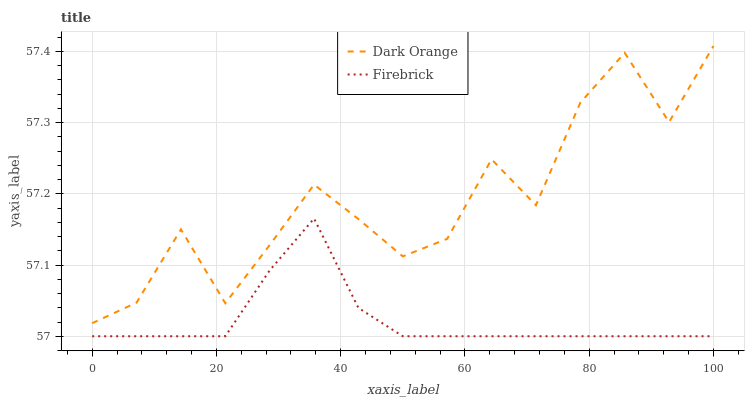Does Firebrick have the minimum area under the curve?
Answer yes or no. Yes. Does Dark Orange have the maximum area under the curve?
Answer yes or no. Yes. Does Firebrick have the maximum area under the curve?
Answer yes or no. No. Is Firebrick the smoothest?
Answer yes or no. Yes. Is Dark Orange the roughest?
Answer yes or no. Yes. Is Firebrick the roughest?
Answer yes or no. No. Does Firebrick have the lowest value?
Answer yes or no. Yes. Does Dark Orange have the highest value?
Answer yes or no. Yes. Does Firebrick have the highest value?
Answer yes or no. No. Is Firebrick less than Dark Orange?
Answer yes or no. Yes. Is Dark Orange greater than Firebrick?
Answer yes or no. Yes. Does Firebrick intersect Dark Orange?
Answer yes or no. No. 